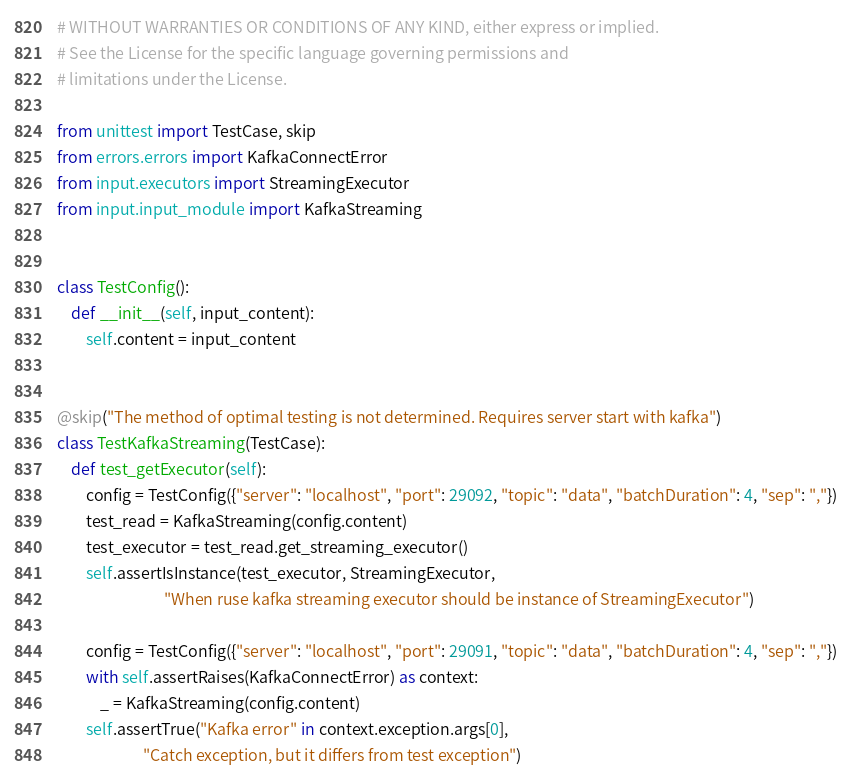Convert code to text. <code><loc_0><loc_0><loc_500><loc_500><_Python_># WITHOUT WARRANTIES OR CONDITIONS OF ANY KIND, either express or implied.
# See the License for the specific language governing permissions and
# limitations under the License.

from unittest import TestCase, skip
from errors.errors import KafkaConnectError
from input.executors import StreamingExecutor
from input.input_module import KafkaStreaming


class TestConfig():
    def __init__(self, input_content):
        self.content = input_content


@skip("The method of optimal testing is not determined. Requires server start with kafka")
class TestKafkaStreaming(TestCase):
    def test_getExecutor(self):
        config = TestConfig({"server": "localhost", "port": 29092, "topic": "data", "batchDuration": 4, "sep": ","})
        test_read = KafkaStreaming(config.content)
        test_executor = test_read.get_streaming_executor()
        self.assertIsInstance(test_executor, StreamingExecutor,
                              "When ruse kafka streaming executor should be instance of StreamingExecutor")

        config = TestConfig({"server": "localhost", "port": 29091, "topic": "data", "batchDuration": 4, "sep": ","})
        with self.assertRaises(KafkaConnectError) as context:
            _ = KafkaStreaming(config.content)
        self.assertTrue("Kafka error" in context.exception.args[0],
                        "Catch exception, but it differs from test exception")
</code> 